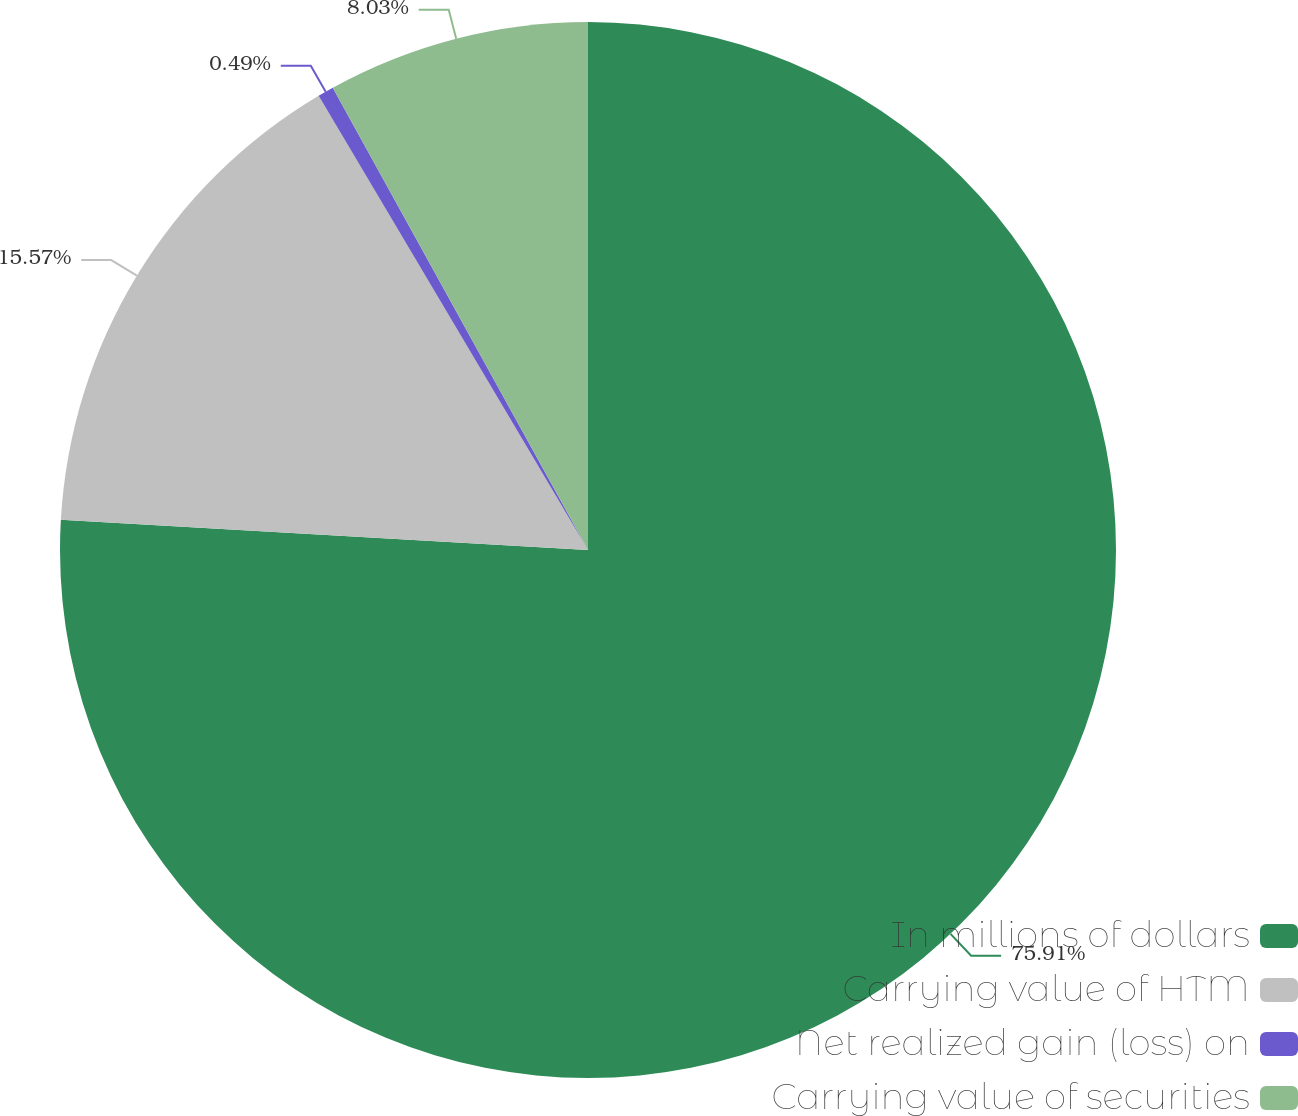Convert chart. <chart><loc_0><loc_0><loc_500><loc_500><pie_chart><fcel>In millions of dollars<fcel>Carrying value of HTM<fcel>Net realized gain (loss) on<fcel>Carrying value of securities<nl><fcel>75.91%<fcel>15.57%<fcel>0.49%<fcel>8.03%<nl></chart> 